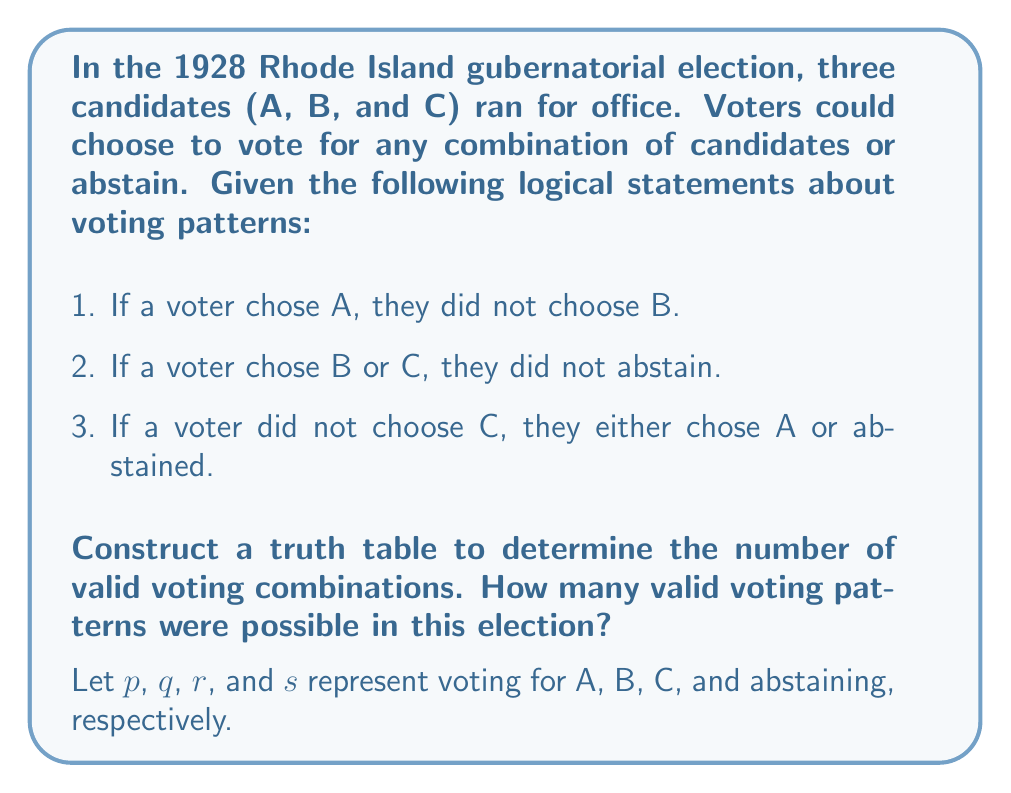Provide a solution to this math problem. Let's approach this step-by-step:

1) First, we need to translate the given statements into logical expressions:
   a) $p \implies \neg q$
   b) $(q \lor r) \implies \neg s$
   c) $\neg r \implies (p \lor s)$

2) Now, let's create a truth table with columns for p, q, r, s, and the three logical expressions:

   | p | q | r | s | $p \implies \neg q$ | $(q \lor r) \implies \neg s$ | $\neg r \implies (p \lor s)$ | Valid |
   |---|---|---|---|---------------------|------------------------------|------------------------------|-------|
   | T | T | T | T | F                   | F                            | T                            | F     |
   | T | T | T | F | F                   | T                            | T                            | F     |
   | T | T | F | T | F                   | F                            | T                            | F     |
   | T | T | F | F | F                   | T                            | T                            | F     |
   | T | F | T | T | T                   | F                            | T                            | F     |
   | T | F | T | F | T                   | T                            | T                            | T     |
   | T | F | F | T | T                   | T                            | T                            | T     |
   | T | F | F | F | T                   | T                            | T                            | T     |
   | F | T | T | T | T                   | F                            | T                            | F     |
   | F | T | T | F | T                   | T                            | T                            | T     |
   | F | T | F | T | T                   | F                            | F                            | F     |
   | F | T | F | F | T                   | T                            | F                            | F     |
   | F | F | T | T | T                   | F                            | T                            | F     |
   | F | F | T | F | T                   | T                            | T                            | T     |
   | F | F | F | T | T                   | T                            | T                            | T     |
   | F | F | F | F | T                   | T                            | T                            | T     |

3) A voting pattern is valid if all three logical expressions are true.

4) Counting the rows where all expressions are true (marked as "Valid"), we find 6 valid voting patterns.

This analysis shows that despite the seemingly complex voting rules, there were still multiple valid ways for voters to express their preferences in this historical Rhode Island election.
Answer: 6 valid voting patterns 